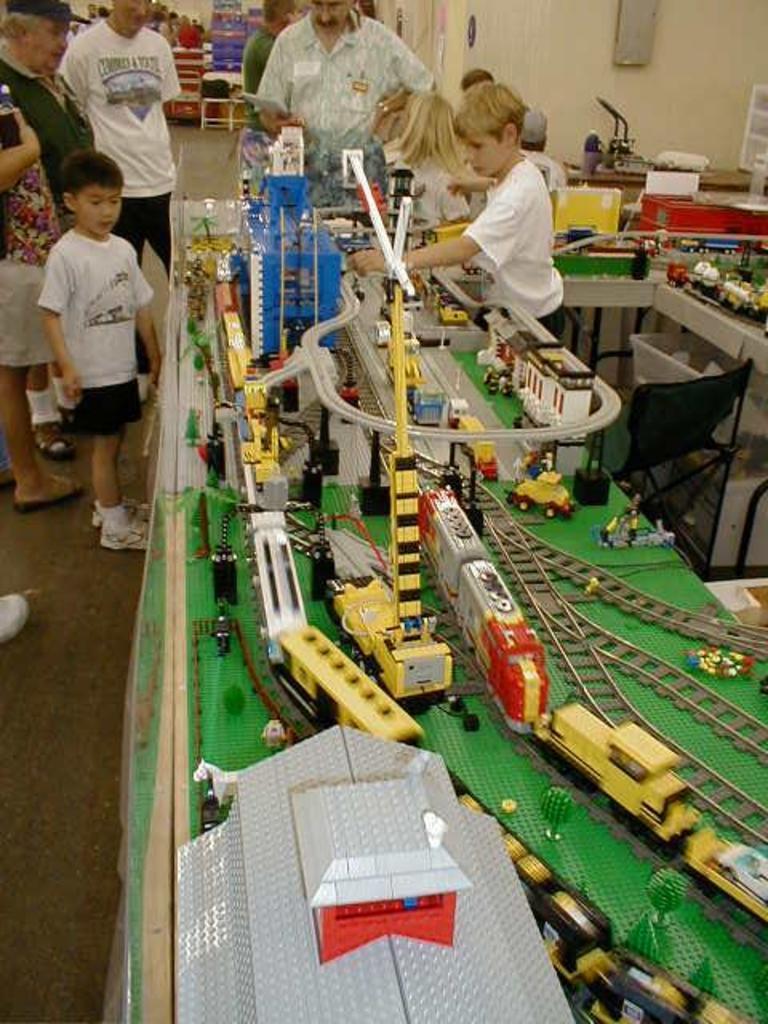Could you give a brief overview of what you see in this image? In this image i can see some toy trains and tracks, and in the background i can see few people watching these toys. 